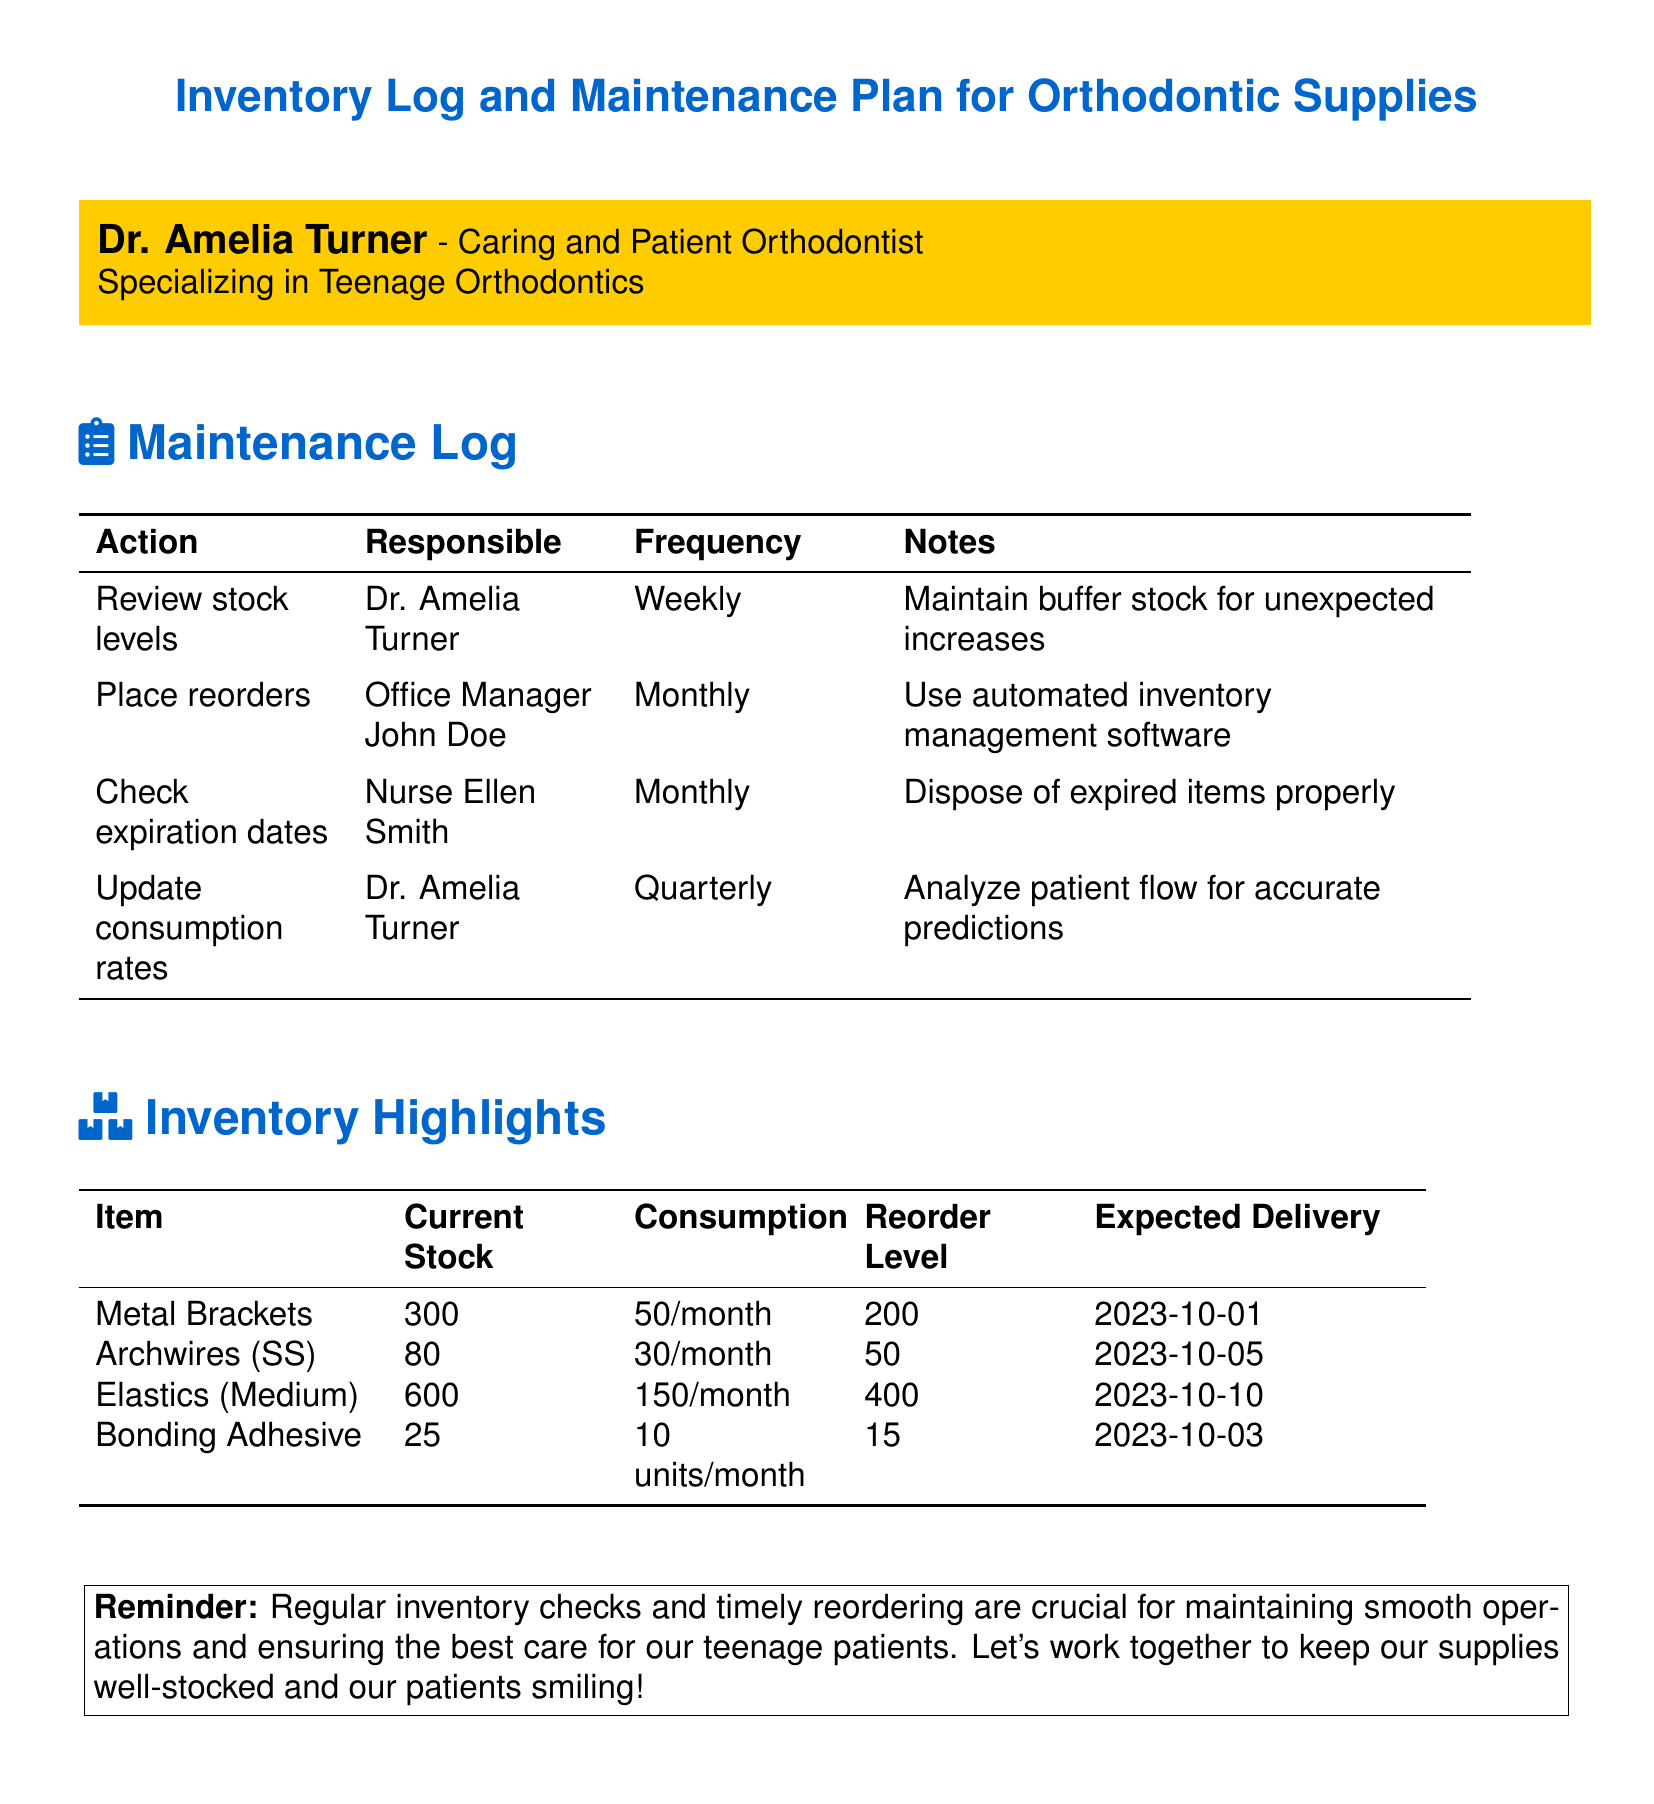What is the name of the orthodontist? The document indicates Dr. Amelia Turner as the orthodontist responsible for the inventory log and maintenance plan.
Answer: Dr. Amelia Turner How often are stock levels reviewed? The maintenance log specifies that stock levels are reviewed weekly to ensure proper inventory management.
Answer: Weekly What is the current stock of archwires? The inventory highlights detail that there are currently 80 archwires in stock.
Answer: 80 When is the expected delivery date for bonding adhesive? The document states that the expected delivery for bonding adhesive is on 2023-10-03.
Answer: 2023-10-03 Who is responsible for placing reorders? According to the maintenance log, the office manager, John Doe, is responsible for placing reorders.
Answer: Office Manager John Doe What is the consumption rate of elastics? The document indicates that the consumption rate for elastics (medium) is 150 per month.
Answer: 150/month What is the reorder level for metal brackets? The inventory highlights specify that the reorder level for metal brackets is set at 200.
Answer: 200 What is the frequency for checking expiration dates? The maintenance log states that expiration dates are checked monthly to ensure safety and compliance.
Answer: Monthly What action is taken quarterly regarding inventory? The document notes that consumption rates are updated quarterly to align with patient flow.
Answer: Update consumption rates 